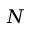<formula> <loc_0><loc_0><loc_500><loc_500>N</formula> 